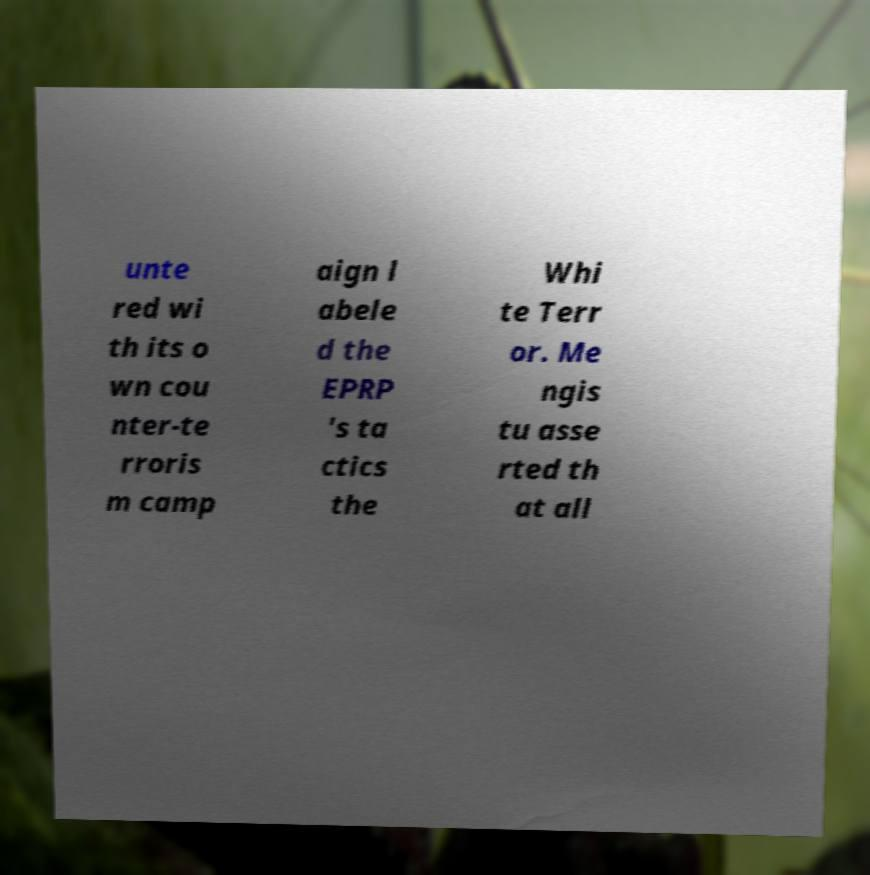What messages or text are displayed in this image? I need them in a readable, typed format. unte red wi th its o wn cou nter-te rroris m camp aign l abele d the EPRP 's ta ctics the Whi te Terr or. Me ngis tu asse rted th at all 